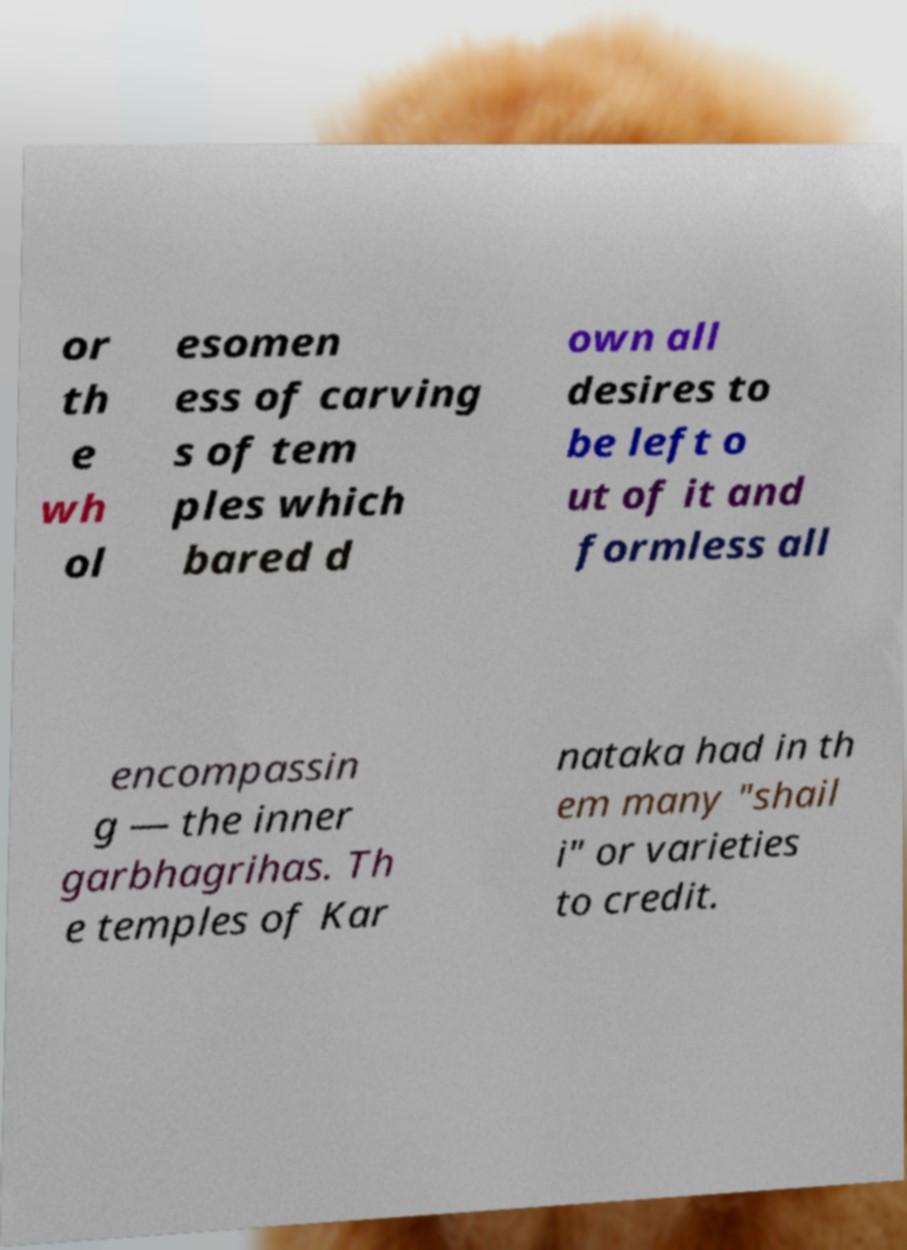Could you extract and type out the text from this image? or th e wh ol esomen ess of carving s of tem ples which bared d own all desires to be left o ut of it and formless all encompassin g — the inner garbhagrihas. Th e temples of Kar nataka had in th em many "shail i" or varieties to credit. 